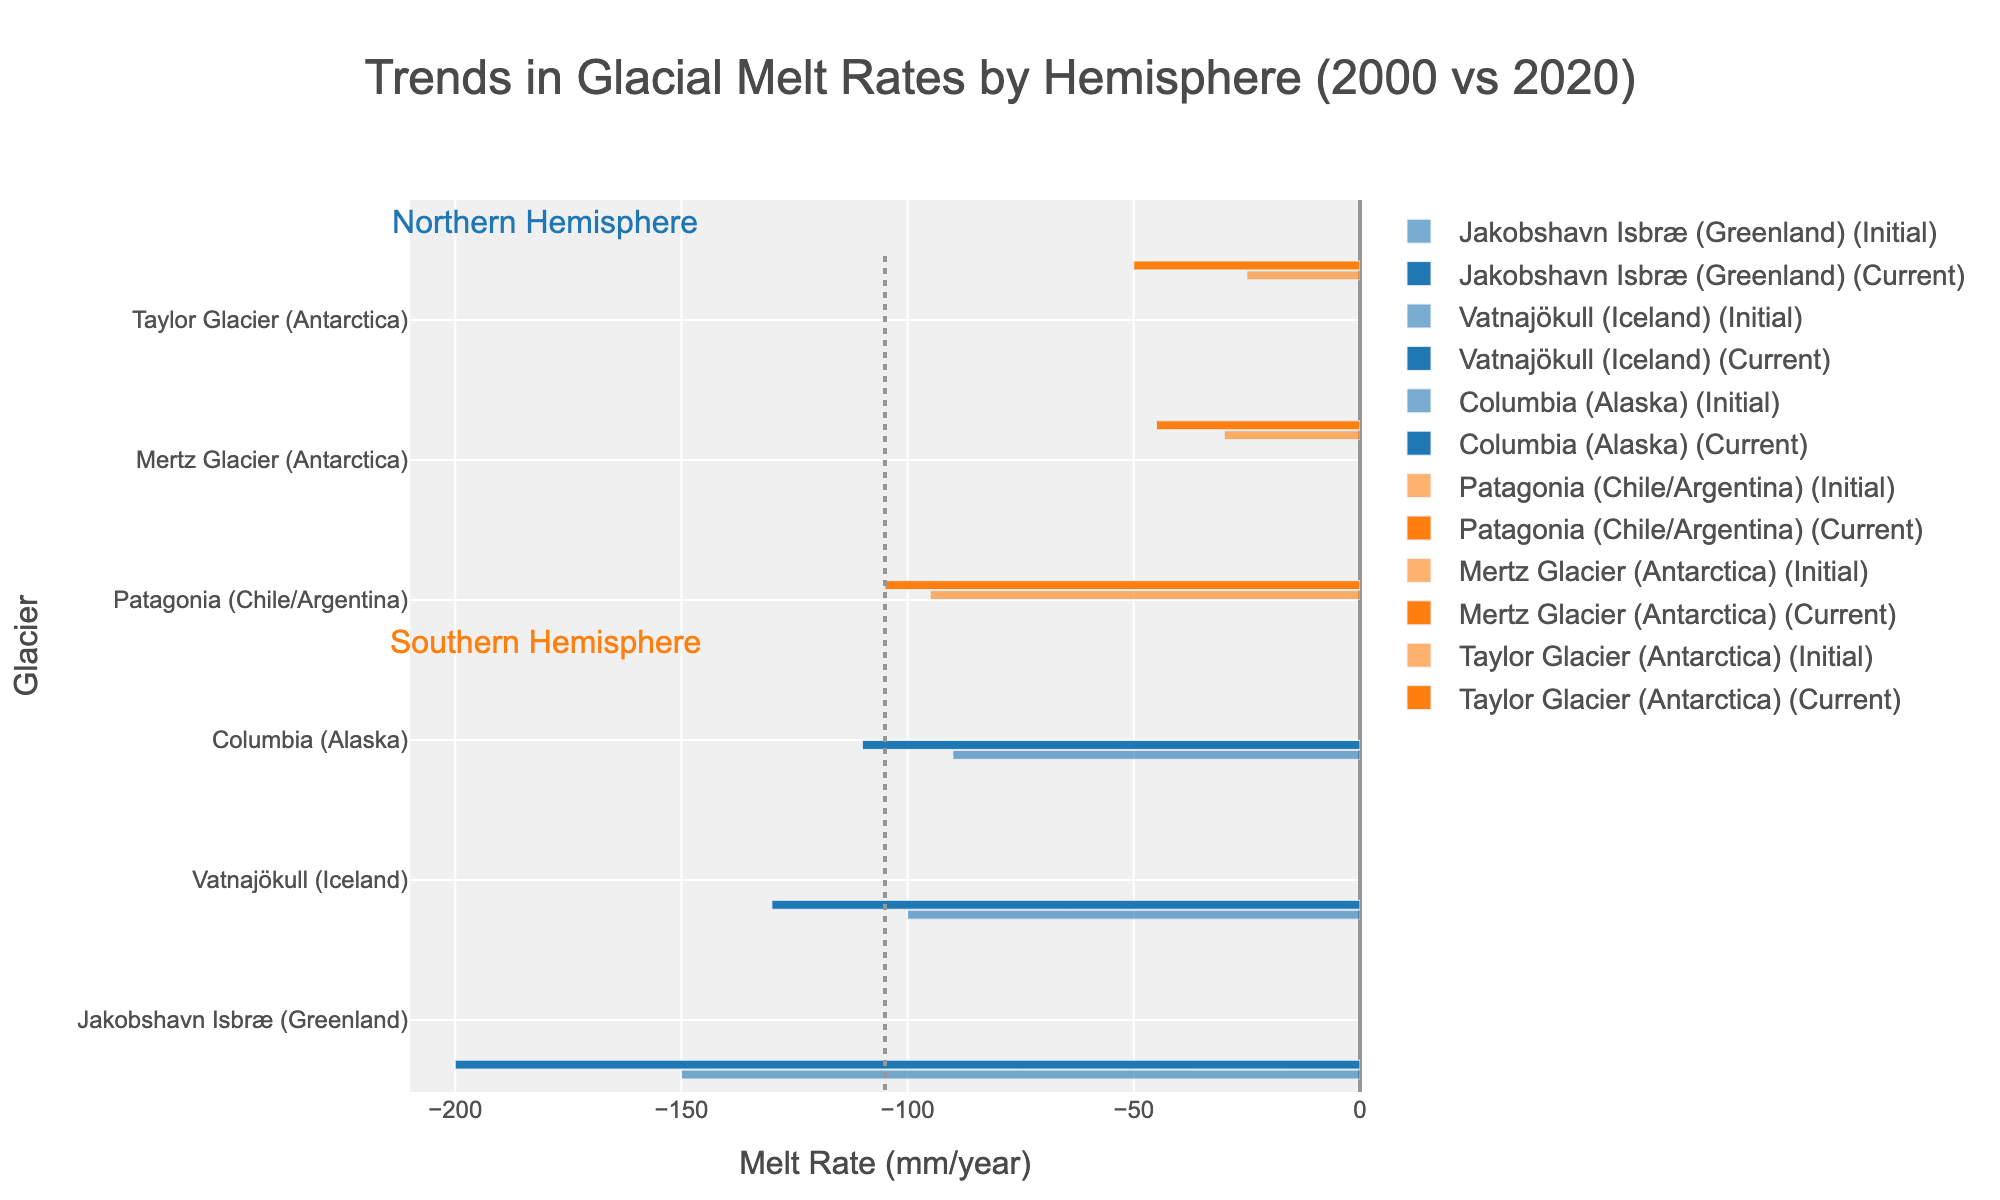Which glacier in the Northern Hemisphere showed the largest increase in its melt rate from 2000 to 2020? Compare the melt rates of Northern Hemisphere glaciers for 2000 and 2020. Jakobshavn Isbræ increased from -150 mm/year to -200 mm/year, which is the largest change compared to others like Vatnajökull and Columbia that showed smaller changes.
Answer: Jakobshavn Isbræ How does the change in melt rate for Mertz Glacier between 2000 and 2020 compare to the change in melt rate for Taylor Glacier over the same period? Compute the changes for Mertz Glacier and Taylor Glacier from their 2000 and 2020 values. The change in melt rate for Mertz Glacier is -15 mm/year (-45 - (-30)), while for Taylor Glacier it is -25 mm/year (-50 - (-25)).
Answer: Taylor Glacier had a larger change Which hemisphere has glaciers with more uniform changes in melt rate from 2000 to 2020? Compare the consistency of the changes in melt rates within each hemisphere. The Southern Hemisphere glaciers (changes of -10, -15, -25 mm/year) show more uniformity compared to the Northern Hemisphere glaciers (changes of -50, -30, -20 mm/year).
Answer: Southern Hemisphere By how much did the melt rate of Vatnajökull change from 2000 to 2020? Subtract the 2020 melt rate of Vatnajökull from the 2000 melt rate. The change is -130 mm/year minus -100 mm/year, which yields a difference of 30 mm/year.
Answer: 30 mm/year Which glacier showed the smallest increase in melt rate over the 20 years? Compare the differences in melt rates between 2000 and 2020 for all glaciers. Mertz Glacier showed the smallest increase, with a change of -15 mm/year.
Answer: Mertz Glacier What is the median change in melt rate for glaciers in the Southern Hemisphere from 2000 to 2020? List the changes in melt rates for the Southern Hemisphere glaciers (-10, -15, -25). Arrange them in numerical order (-25, -15, -10). The median is the middle value, which is -15 mm/year.
Answer: -15 mm/year How much greater is the 2020 melt rate of Jakobshavn Isbræ compared to the 2020 melt rate of Columbia Glacier? Compare the 2020 melt rates of Jakobshavn Isbræ and Columbia Glacier. Jakobshavn Isbræ has a rate of -200 mm/year and Columbia has -110 mm/year. Subtract -110 from -200 to find the difference.
Answer: 90 mm/year What is the total change in melt rate for all glaciers in the Southern Hemisphere from 2000 to 2020? Add up the changes for all Southern Hemisphere glaciers: -10 (Patagonia) + -15 (Mertz) + -25 (Taylor). The total change is -50 mm/year.
Answer: -50 mm/year Which hemisphere is more affected by increasing melt rates of glaciers as shown by the chart? By examining the length of the bars in 2020, you can visually compare both hemispheres. The Northern Hemisphere has more significant and larger changes indicating it is more affected.
Answer: Northern Hemisphere 